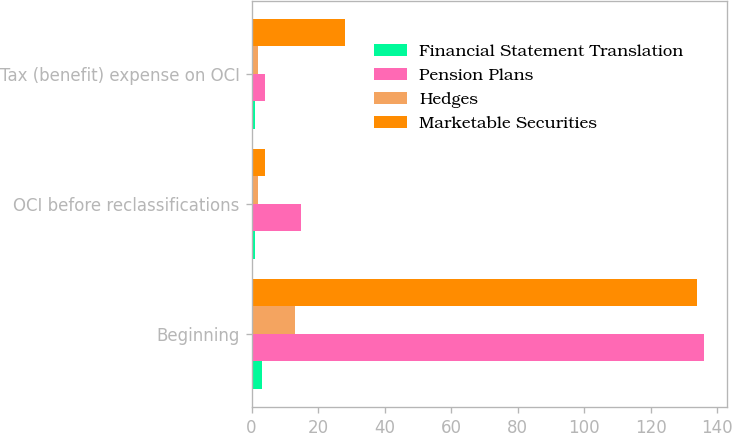Convert chart. <chart><loc_0><loc_0><loc_500><loc_500><stacked_bar_chart><ecel><fcel>Beginning<fcel>OCI before reclassifications<fcel>Tax (benefit) expense on OCI<nl><fcel>Financial Statement Translation<fcel>3<fcel>1<fcel>1<nl><fcel>Pension Plans<fcel>136<fcel>15<fcel>4<nl><fcel>Hedges<fcel>13<fcel>2<fcel>2<nl><fcel>Marketable Securities<fcel>134<fcel>4<fcel>28<nl></chart> 